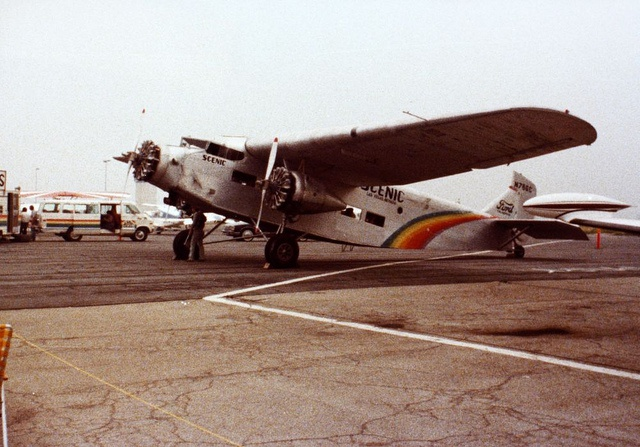Describe the objects in this image and their specific colors. I can see airplane in white, black, maroon, gray, and brown tones, bus in white, black, lightgray, gray, and maroon tones, people in white, black, maroon, and brown tones, airplane in white, lightgray, darkgray, maroon, and gray tones, and car in white, black, maroon, brown, and lightgray tones in this image. 